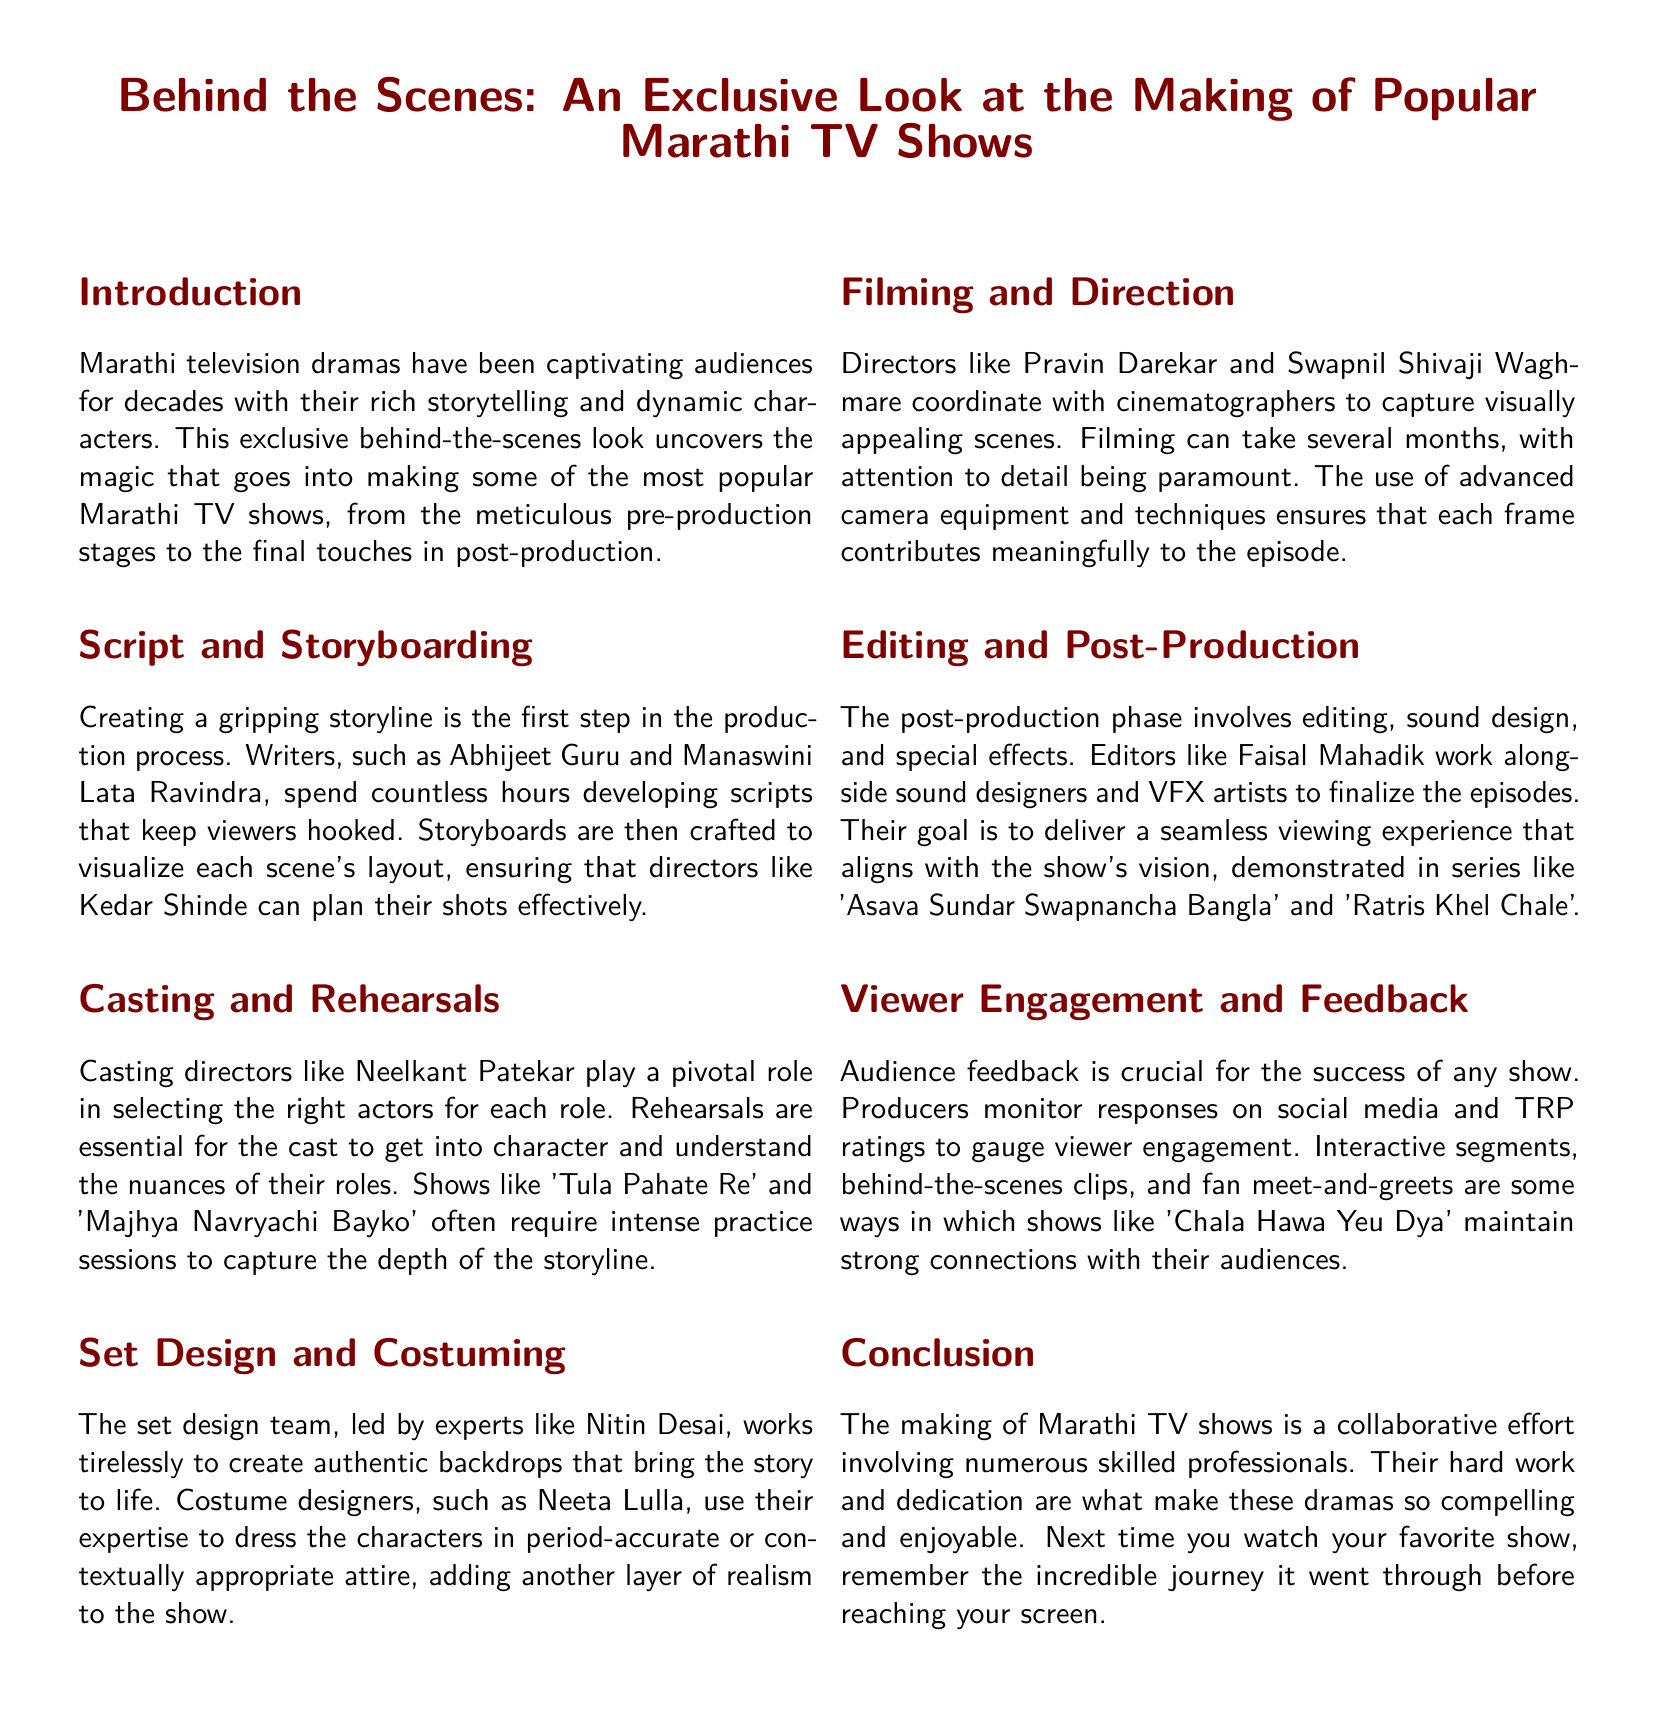What is the primary focus of the article? The article provides an exclusive look at the making of popular Marathi TV shows, covering various production stages.
Answer: making of popular Marathi TV shows Who are two writers mentioned in the document? The document refers to writers Abhijeet Guru and Manaswini Lata Ravindra.
Answer: Abhijeet Guru and Manaswini Lata Ravindra Which show is directed by Kedar Shinde? Kedar Shinde is associated with directing that requires meticulous planning of shots based on storyboards.
Answer: shows like 'Tula Pahate Re' and 'Majhya Navryachi Bayko' Who leads the set design team? The set design team is led by expert Nitin Desai.
Answer: Nitin Desai What is the role of Faisal Mahadik in production? Faisal Mahadik works as an editor during post-production.
Answer: editor How many phases are mentioned in the making of a TV show? The document details six phases in the making of a TV show.
Answer: six What is the significance of audience feedback? Audience feedback is crucial for gauging viewer engagement and the success of any show.
Answer: success of any show Which show emphasizes audience engagement through interactive segments? The document mentions 'Chala Hawa Yeu Dya' for maintaining audience connections.
Answer: 'Chala Hawa Yeu Dya' 